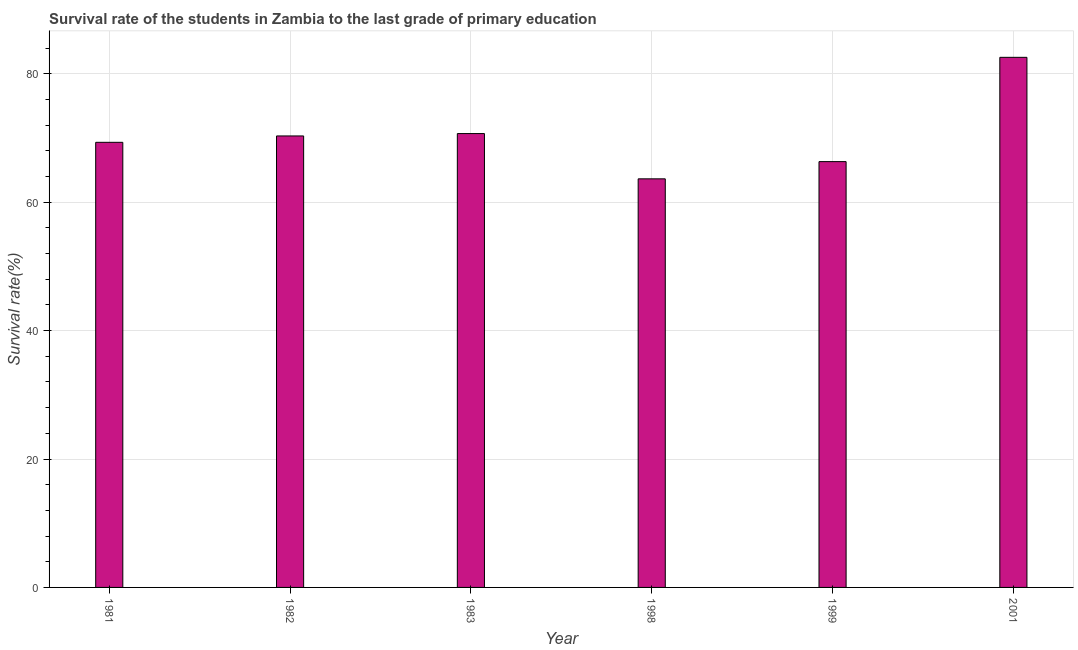Does the graph contain any zero values?
Provide a short and direct response. No. Does the graph contain grids?
Provide a succinct answer. Yes. What is the title of the graph?
Make the answer very short. Survival rate of the students in Zambia to the last grade of primary education. What is the label or title of the Y-axis?
Ensure brevity in your answer.  Survival rate(%). What is the survival rate in primary education in 1998?
Your response must be concise. 63.64. Across all years, what is the maximum survival rate in primary education?
Offer a terse response. 82.57. Across all years, what is the minimum survival rate in primary education?
Give a very brief answer. 63.64. In which year was the survival rate in primary education minimum?
Your response must be concise. 1998. What is the sum of the survival rate in primary education?
Provide a short and direct response. 422.9. What is the difference between the survival rate in primary education in 1983 and 1998?
Provide a short and direct response. 7.05. What is the average survival rate in primary education per year?
Offer a terse response. 70.48. What is the median survival rate in primary education?
Keep it short and to the point. 69.83. In how many years, is the survival rate in primary education greater than 76 %?
Offer a very short reply. 1. What is the ratio of the survival rate in primary education in 1982 to that in 2001?
Offer a terse response. 0.85. What is the difference between the highest and the second highest survival rate in primary education?
Ensure brevity in your answer.  11.88. What is the difference between the highest and the lowest survival rate in primary education?
Give a very brief answer. 18.93. In how many years, is the survival rate in primary education greater than the average survival rate in primary education taken over all years?
Provide a short and direct response. 2. Are all the bars in the graph horizontal?
Ensure brevity in your answer.  No. How many years are there in the graph?
Your answer should be very brief. 6. What is the difference between two consecutive major ticks on the Y-axis?
Offer a terse response. 20. Are the values on the major ticks of Y-axis written in scientific E-notation?
Offer a very short reply. No. What is the Survival rate(%) in 1981?
Give a very brief answer. 69.33. What is the Survival rate(%) in 1982?
Provide a short and direct response. 70.33. What is the Survival rate(%) in 1983?
Provide a succinct answer. 70.7. What is the Survival rate(%) in 1998?
Give a very brief answer. 63.64. What is the Survival rate(%) in 1999?
Provide a short and direct response. 66.33. What is the Survival rate(%) in 2001?
Your answer should be compact. 82.57. What is the difference between the Survival rate(%) in 1981 and 1982?
Keep it short and to the point. -1. What is the difference between the Survival rate(%) in 1981 and 1983?
Offer a very short reply. -1.36. What is the difference between the Survival rate(%) in 1981 and 1998?
Your answer should be compact. 5.69. What is the difference between the Survival rate(%) in 1981 and 1999?
Your answer should be compact. 3. What is the difference between the Survival rate(%) in 1981 and 2001?
Your response must be concise. -13.24. What is the difference between the Survival rate(%) in 1982 and 1983?
Your answer should be compact. -0.37. What is the difference between the Survival rate(%) in 1982 and 1998?
Your response must be concise. 6.68. What is the difference between the Survival rate(%) in 1982 and 1999?
Ensure brevity in your answer.  4. What is the difference between the Survival rate(%) in 1982 and 2001?
Make the answer very short. -12.24. What is the difference between the Survival rate(%) in 1983 and 1998?
Provide a short and direct response. 7.05. What is the difference between the Survival rate(%) in 1983 and 1999?
Your response must be concise. 4.37. What is the difference between the Survival rate(%) in 1983 and 2001?
Ensure brevity in your answer.  -11.88. What is the difference between the Survival rate(%) in 1998 and 1999?
Ensure brevity in your answer.  -2.68. What is the difference between the Survival rate(%) in 1998 and 2001?
Make the answer very short. -18.93. What is the difference between the Survival rate(%) in 1999 and 2001?
Your answer should be compact. -16.24. What is the ratio of the Survival rate(%) in 1981 to that in 1983?
Your answer should be very brief. 0.98. What is the ratio of the Survival rate(%) in 1981 to that in 1998?
Provide a succinct answer. 1.09. What is the ratio of the Survival rate(%) in 1981 to that in 1999?
Offer a very short reply. 1.04. What is the ratio of the Survival rate(%) in 1981 to that in 2001?
Keep it short and to the point. 0.84. What is the ratio of the Survival rate(%) in 1982 to that in 1983?
Keep it short and to the point. 0.99. What is the ratio of the Survival rate(%) in 1982 to that in 1998?
Offer a terse response. 1.1. What is the ratio of the Survival rate(%) in 1982 to that in 1999?
Your answer should be compact. 1.06. What is the ratio of the Survival rate(%) in 1982 to that in 2001?
Make the answer very short. 0.85. What is the ratio of the Survival rate(%) in 1983 to that in 1998?
Make the answer very short. 1.11. What is the ratio of the Survival rate(%) in 1983 to that in 1999?
Give a very brief answer. 1.07. What is the ratio of the Survival rate(%) in 1983 to that in 2001?
Ensure brevity in your answer.  0.86. What is the ratio of the Survival rate(%) in 1998 to that in 1999?
Give a very brief answer. 0.96. What is the ratio of the Survival rate(%) in 1998 to that in 2001?
Your response must be concise. 0.77. What is the ratio of the Survival rate(%) in 1999 to that in 2001?
Make the answer very short. 0.8. 